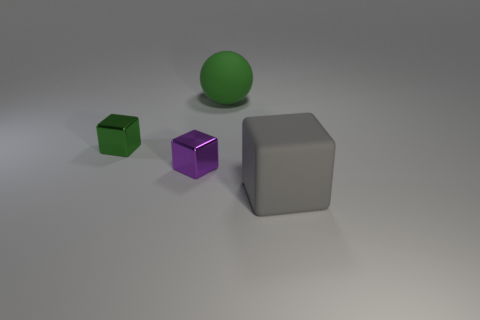Add 2 purple metal things. How many objects exist? 6 Subtract all tiny blocks. How many blocks are left? 1 Add 4 green matte objects. How many green matte objects are left? 5 Add 2 small brown things. How many small brown things exist? 2 Subtract all green blocks. How many blocks are left? 2 Subtract 0 brown spheres. How many objects are left? 4 Subtract all cubes. How many objects are left? 1 Subtract 1 cubes. How many cubes are left? 2 Subtract all red spheres. Subtract all purple blocks. How many spheres are left? 1 Subtract all big blue cubes. Subtract all gray matte objects. How many objects are left? 3 